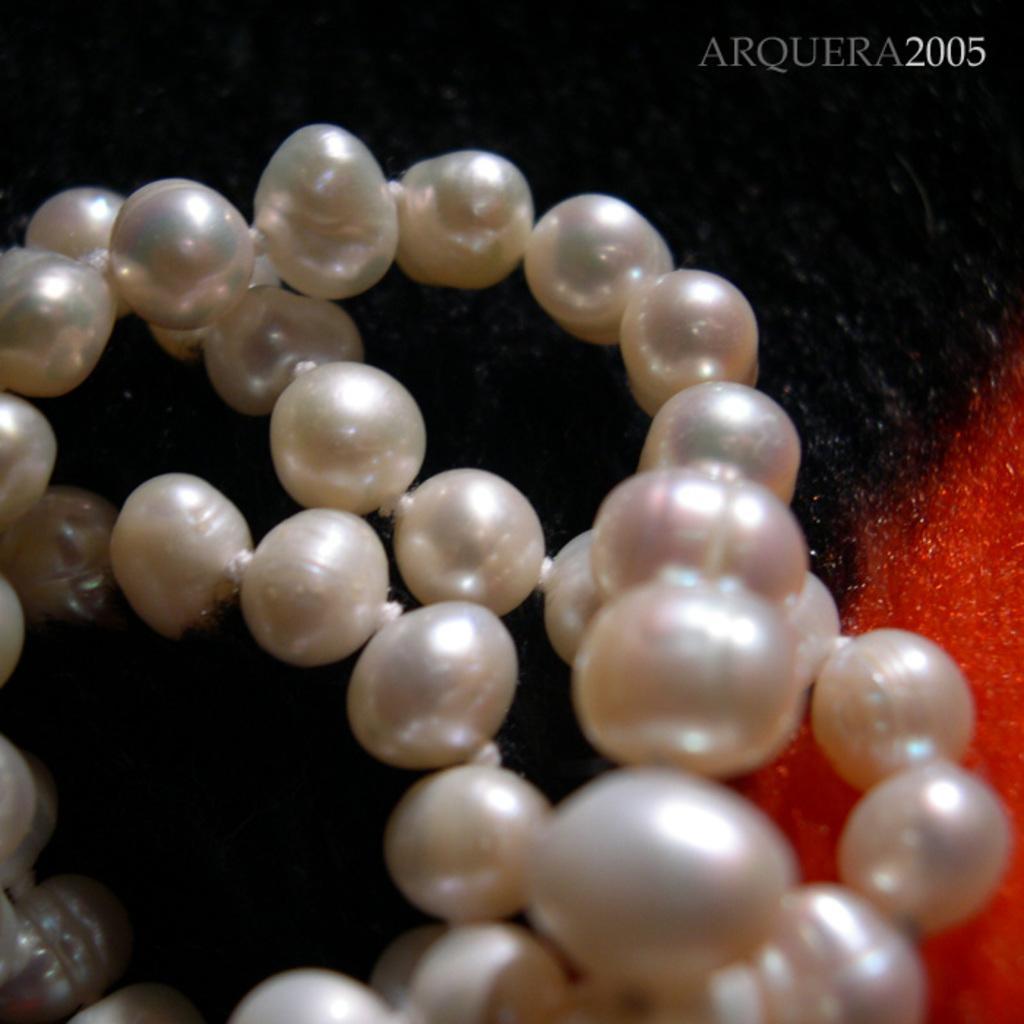In one or two sentences, can you explain what this image depicts? In this image, we can see some pearls which are placed on the mat, which is in black and red color. 